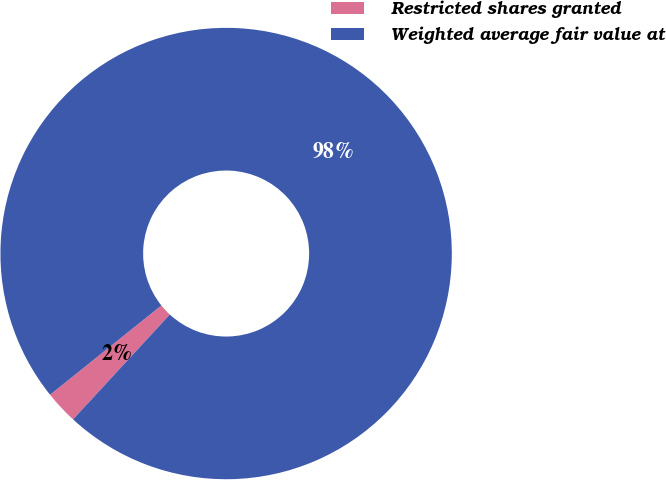<chart> <loc_0><loc_0><loc_500><loc_500><pie_chart><fcel>Restricted shares granted<fcel>Weighted average fair value at<nl><fcel>2.38%<fcel>97.62%<nl></chart> 